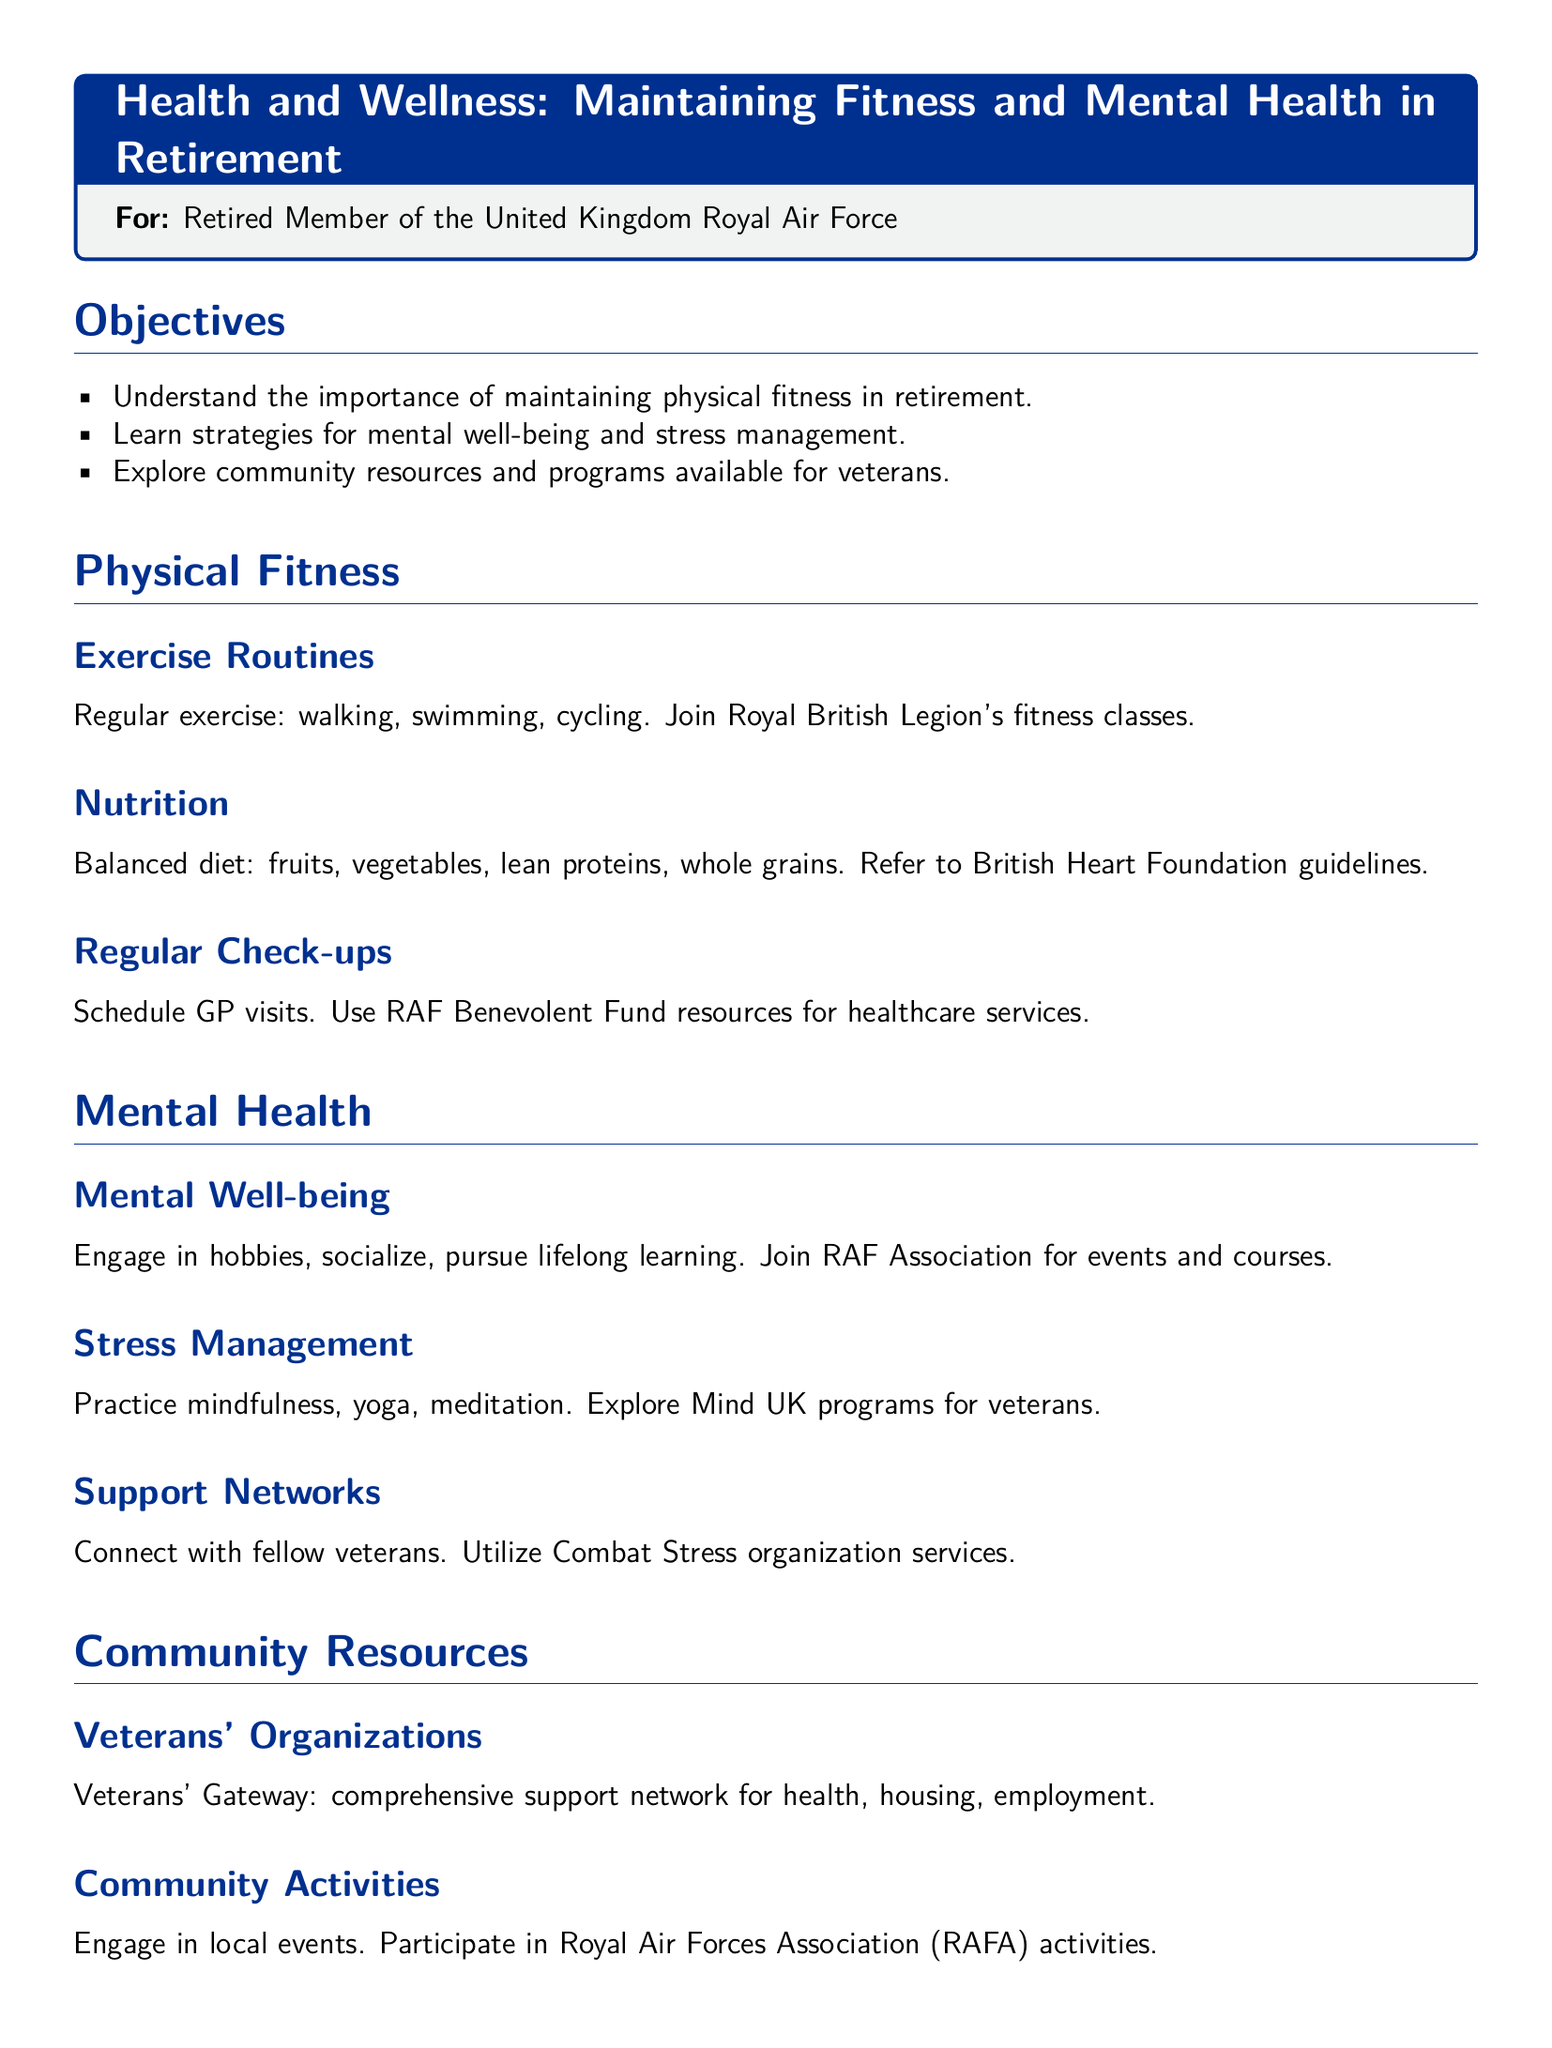What is the title of the lesson plan? The title is stated at the beginning of the document in a highlighted box.
Answer: Health and Wellness: Maintaining Fitness and Mental Health in Retirement What is one type of exercise mentioned? The document lists various exercise routines that can be incorporated into a fitness plan.
Answer: Walking Which organization offers fitness classes for veterans? In the document, a specific veteran organization is credited with providing fitness classes.
Answer: Royal British Legion What is one component of a balanced diet according to the document? The lesson plan outlines essential dietary elements that contribute to overall health.
Answer: Fruits What is a strategy for mental well-being listed in the document? The document provides a list of activities that support mental health among retirees.
Answer: Hobbies What is the purpose of the RAF Association mentioned in the document? The RAF Association is introduced as a resource for events and courses for veterans.
Answer: Events and courses Which organization helps with stress management? The document names a specific organization that provides programs targeting stress reduction for veterans.
Answer: Mind UK How often should GP visits be scheduled according to the suggestions? The document implies a routine aspect related to healthcare check-ups.
Answer: Regularly What is the conclusion about maintaining fitness and mental health? The conclusion summarizes key takeaways regarding health in retirement.
Answer: Crucial 